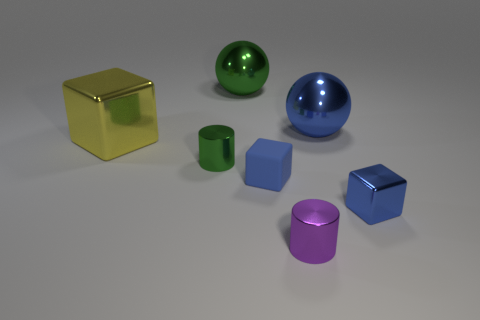Add 2 green rubber blocks. How many objects exist? 9 Subtract all spheres. How many objects are left? 5 Subtract 0 red cylinders. How many objects are left? 7 Subtract all big blue shiny spheres. Subtract all cylinders. How many objects are left? 4 Add 6 tiny blue cubes. How many tiny blue cubes are left? 8 Add 5 big blue objects. How many big blue objects exist? 6 